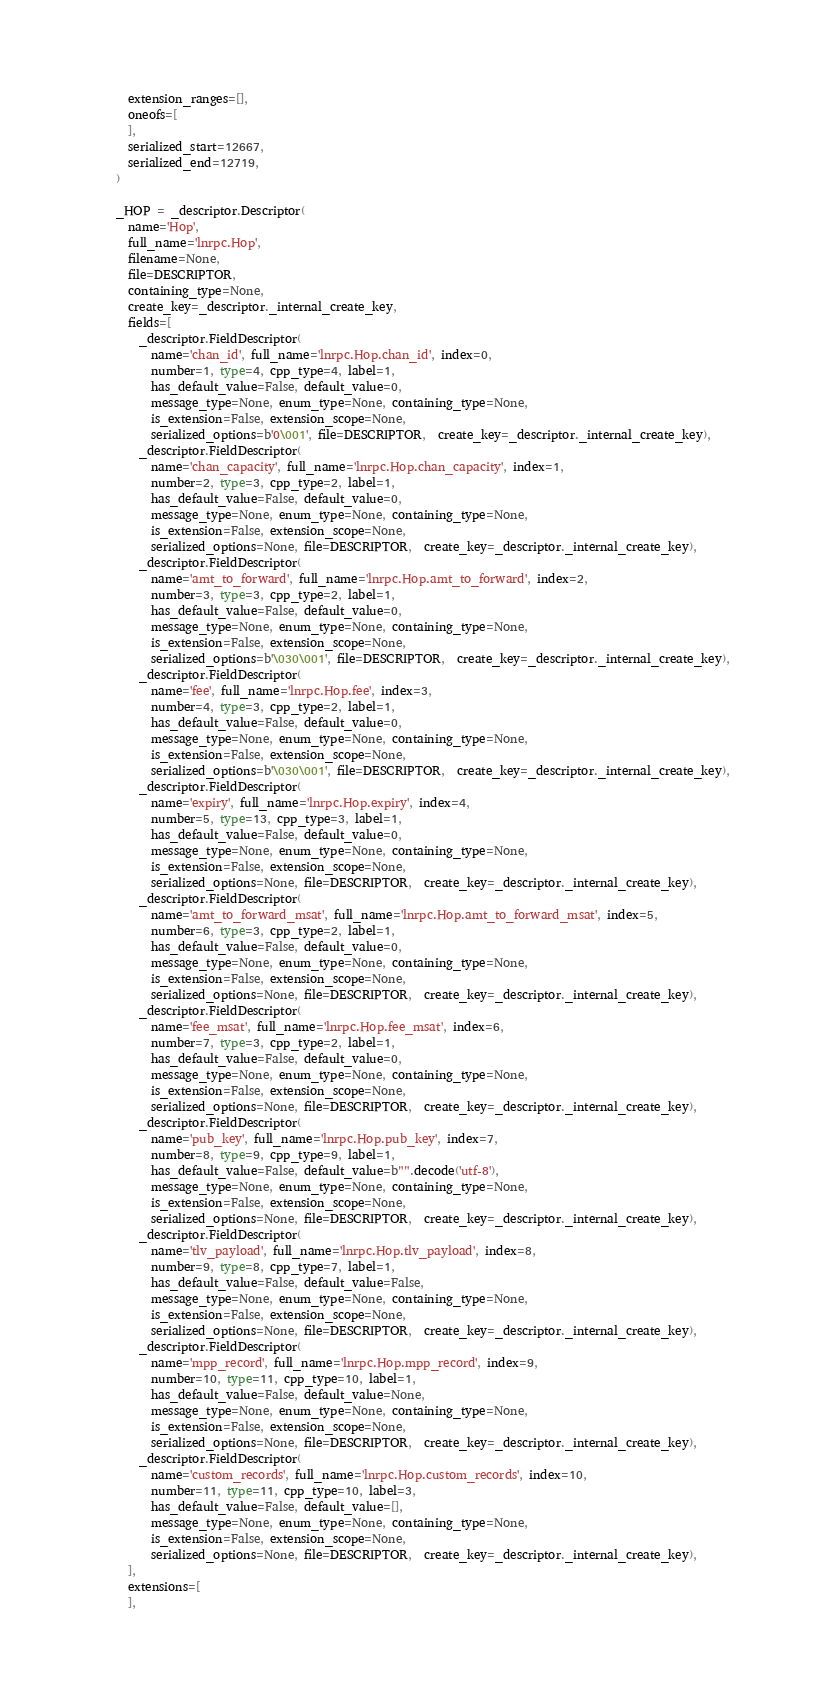<code> <loc_0><loc_0><loc_500><loc_500><_Python_>  extension_ranges=[],
  oneofs=[
  ],
  serialized_start=12667,
  serialized_end=12719,
)

_HOP = _descriptor.Descriptor(
  name='Hop',
  full_name='lnrpc.Hop',
  filename=None,
  file=DESCRIPTOR,
  containing_type=None,
  create_key=_descriptor._internal_create_key,
  fields=[
    _descriptor.FieldDescriptor(
      name='chan_id', full_name='lnrpc.Hop.chan_id', index=0,
      number=1, type=4, cpp_type=4, label=1,
      has_default_value=False, default_value=0,
      message_type=None, enum_type=None, containing_type=None,
      is_extension=False, extension_scope=None,
      serialized_options=b'0\001', file=DESCRIPTOR,  create_key=_descriptor._internal_create_key),
    _descriptor.FieldDescriptor(
      name='chan_capacity', full_name='lnrpc.Hop.chan_capacity', index=1,
      number=2, type=3, cpp_type=2, label=1,
      has_default_value=False, default_value=0,
      message_type=None, enum_type=None, containing_type=None,
      is_extension=False, extension_scope=None,
      serialized_options=None, file=DESCRIPTOR,  create_key=_descriptor._internal_create_key),
    _descriptor.FieldDescriptor(
      name='amt_to_forward', full_name='lnrpc.Hop.amt_to_forward', index=2,
      number=3, type=3, cpp_type=2, label=1,
      has_default_value=False, default_value=0,
      message_type=None, enum_type=None, containing_type=None,
      is_extension=False, extension_scope=None,
      serialized_options=b'\030\001', file=DESCRIPTOR,  create_key=_descriptor._internal_create_key),
    _descriptor.FieldDescriptor(
      name='fee', full_name='lnrpc.Hop.fee', index=3,
      number=4, type=3, cpp_type=2, label=1,
      has_default_value=False, default_value=0,
      message_type=None, enum_type=None, containing_type=None,
      is_extension=False, extension_scope=None,
      serialized_options=b'\030\001', file=DESCRIPTOR,  create_key=_descriptor._internal_create_key),
    _descriptor.FieldDescriptor(
      name='expiry', full_name='lnrpc.Hop.expiry', index=4,
      number=5, type=13, cpp_type=3, label=1,
      has_default_value=False, default_value=0,
      message_type=None, enum_type=None, containing_type=None,
      is_extension=False, extension_scope=None,
      serialized_options=None, file=DESCRIPTOR,  create_key=_descriptor._internal_create_key),
    _descriptor.FieldDescriptor(
      name='amt_to_forward_msat', full_name='lnrpc.Hop.amt_to_forward_msat', index=5,
      number=6, type=3, cpp_type=2, label=1,
      has_default_value=False, default_value=0,
      message_type=None, enum_type=None, containing_type=None,
      is_extension=False, extension_scope=None,
      serialized_options=None, file=DESCRIPTOR,  create_key=_descriptor._internal_create_key),
    _descriptor.FieldDescriptor(
      name='fee_msat', full_name='lnrpc.Hop.fee_msat', index=6,
      number=7, type=3, cpp_type=2, label=1,
      has_default_value=False, default_value=0,
      message_type=None, enum_type=None, containing_type=None,
      is_extension=False, extension_scope=None,
      serialized_options=None, file=DESCRIPTOR,  create_key=_descriptor._internal_create_key),
    _descriptor.FieldDescriptor(
      name='pub_key', full_name='lnrpc.Hop.pub_key', index=7,
      number=8, type=9, cpp_type=9, label=1,
      has_default_value=False, default_value=b"".decode('utf-8'),
      message_type=None, enum_type=None, containing_type=None,
      is_extension=False, extension_scope=None,
      serialized_options=None, file=DESCRIPTOR,  create_key=_descriptor._internal_create_key),
    _descriptor.FieldDescriptor(
      name='tlv_payload', full_name='lnrpc.Hop.tlv_payload', index=8,
      number=9, type=8, cpp_type=7, label=1,
      has_default_value=False, default_value=False,
      message_type=None, enum_type=None, containing_type=None,
      is_extension=False, extension_scope=None,
      serialized_options=None, file=DESCRIPTOR,  create_key=_descriptor._internal_create_key),
    _descriptor.FieldDescriptor(
      name='mpp_record', full_name='lnrpc.Hop.mpp_record', index=9,
      number=10, type=11, cpp_type=10, label=1,
      has_default_value=False, default_value=None,
      message_type=None, enum_type=None, containing_type=None,
      is_extension=False, extension_scope=None,
      serialized_options=None, file=DESCRIPTOR,  create_key=_descriptor._internal_create_key),
    _descriptor.FieldDescriptor(
      name='custom_records', full_name='lnrpc.Hop.custom_records', index=10,
      number=11, type=11, cpp_type=10, label=3,
      has_default_value=False, default_value=[],
      message_type=None, enum_type=None, containing_type=None,
      is_extension=False, extension_scope=None,
      serialized_options=None, file=DESCRIPTOR,  create_key=_descriptor._internal_create_key),
  ],
  extensions=[
  ],</code> 